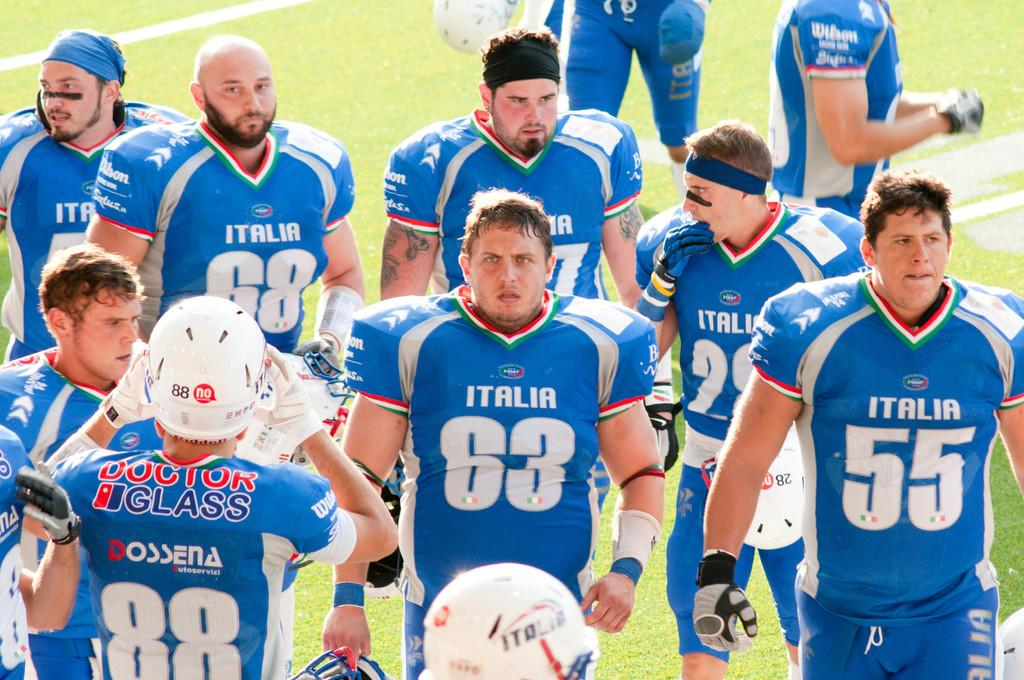Provide a one-sentence caption for the provided image. A football team from Italia stand on the field. 